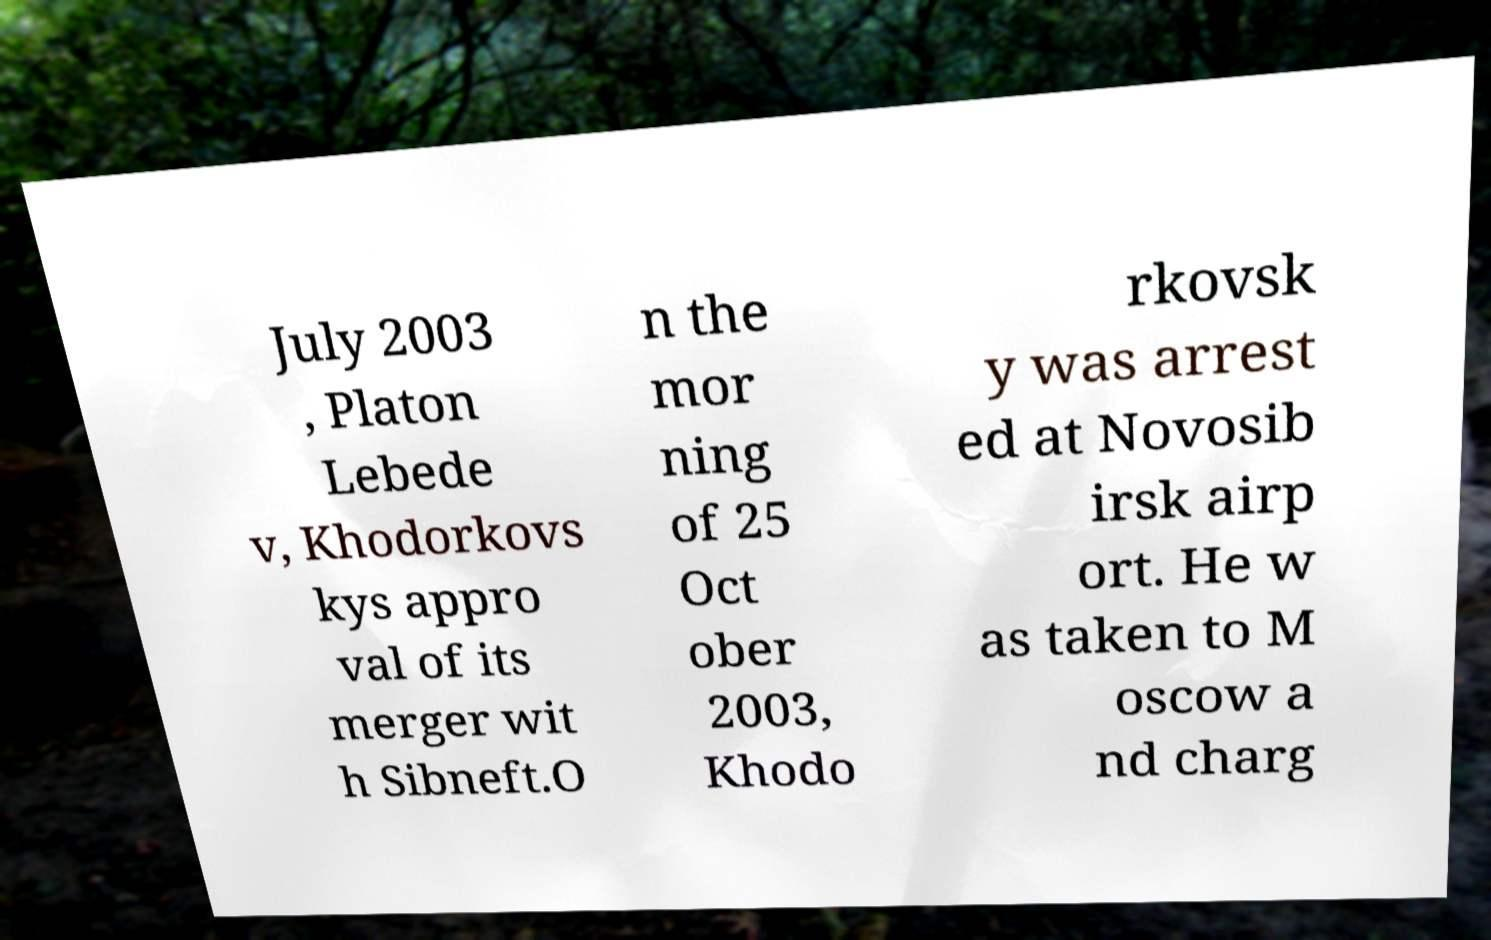Please read and relay the text visible in this image. What does it say? July 2003 , Platon Lebede v, Khodorkovs kys appro val of its merger wit h Sibneft.O n the mor ning of 25 Oct ober 2003, Khodo rkovsk y was arrest ed at Novosib irsk airp ort. He w as taken to M oscow a nd charg 